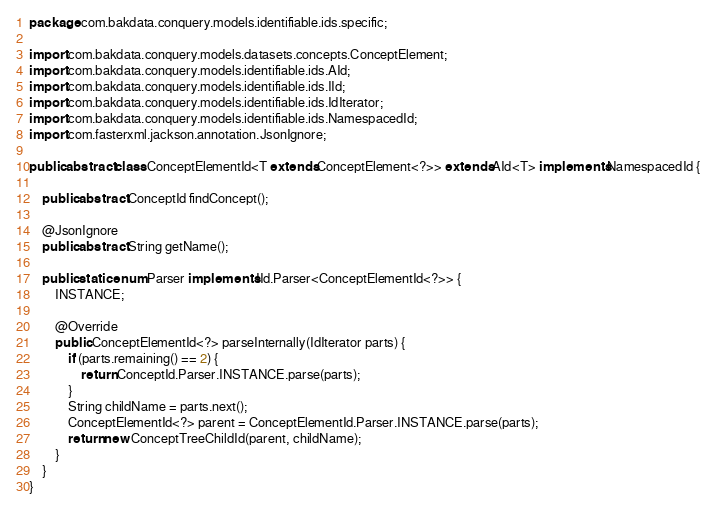<code> <loc_0><loc_0><loc_500><loc_500><_Java_>package com.bakdata.conquery.models.identifiable.ids.specific;

import com.bakdata.conquery.models.datasets.concepts.ConceptElement;
import com.bakdata.conquery.models.identifiable.ids.AId;
import com.bakdata.conquery.models.identifiable.ids.IId;
import com.bakdata.conquery.models.identifiable.ids.IdIterator;
import com.bakdata.conquery.models.identifiable.ids.NamespacedId;
import com.fasterxml.jackson.annotation.JsonIgnore;

public abstract class ConceptElementId<T extends ConceptElement<?>> extends AId<T> implements NamespacedId {

	public abstract ConceptId findConcept();

	@JsonIgnore
	public abstract String getName();

	public static enum Parser implements IId.Parser<ConceptElementId<?>> {
		INSTANCE;

		@Override
		public ConceptElementId<?> parseInternally(IdIterator parts) {
			if (parts.remaining() == 2) {
				return ConceptId.Parser.INSTANCE.parse(parts);
			}
			String childName = parts.next();
			ConceptElementId<?> parent = ConceptElementId.Parser.INSTANCE.parse(parts);
			return new ConceptTreeChildId(parent, childName);
		}
	}
}
</code> 